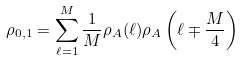Convert formula to latex. <formula><loc_0><loc_0><loc_500><loc_500>\rho _ { 0 , 1 } = \sum ^ { M } _ { \ell = 1 } \frac { 1 } { M } \rho _ { A } ( \ell ) \rho _ { A } \left ( \ell \mp \frac { M } { 4 } \right )</formula> 